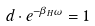<formula> <loc_0><loc_0><loc_500><loc_500>d \cdot e ^ { - \beta _ { H } \omega } = 1</formula> 